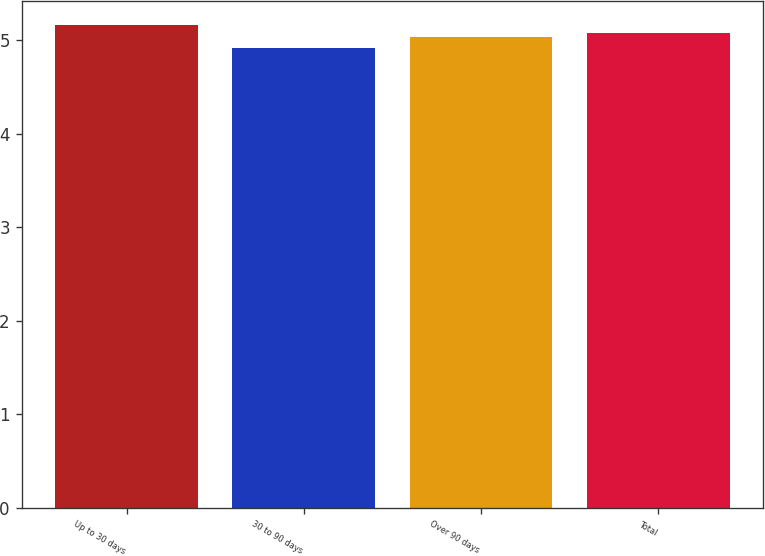<chart> <loc_0><loc_0><loc_500><loc_500><bar_chart><fcel>Up to 30 days<fcel>30 to 90 days<fcel>Over 90 days<fcel>Total<nl><fcel>5.16<fcel>4.92<fcel>5.03<fcel>5.08<nl></chart> 